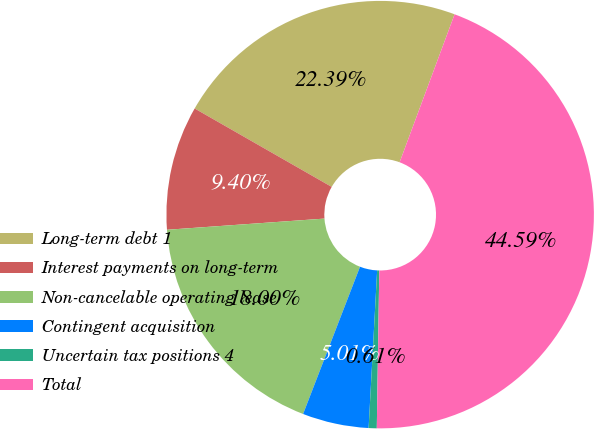Convert chart. <chart><loc_0><loc_0><loc_500><loc_500><pie_chart><fcel>Long-term debt 1<fcel>Interest payments on long-term<fcel>Non-cancelable operating lease<fcel>Contingent acquisition<fcel>Uncertain tax positions 4<fcel>Total<nl><fcel>22.39%<fcel>9.4%<fcel>18.0%<fcel>5.01%<fcel>0.61%<fcel>44.59%<nl></chart> 